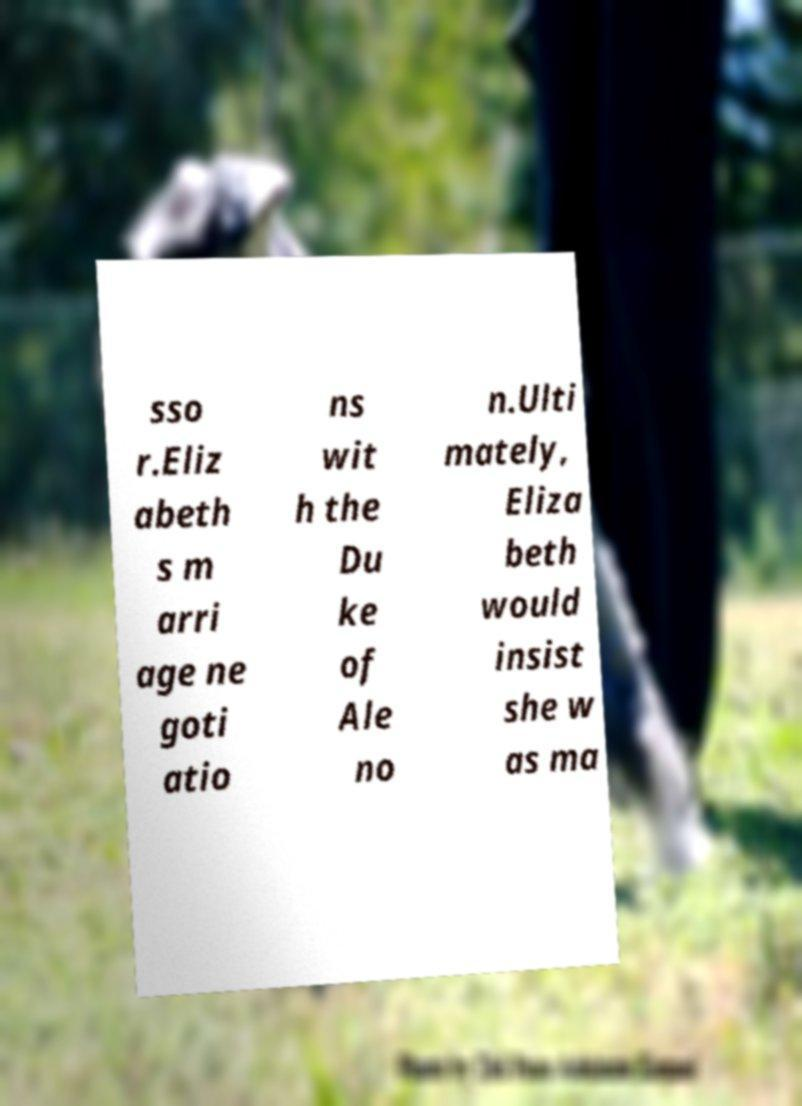Please read and relay the text visible in this image. What does it say? sso r.Eliz abeth s m arri age ne goti atio ns wit h the Du ke of Ale no n.Ulti mately, Eliza beth would insist she w as ma 